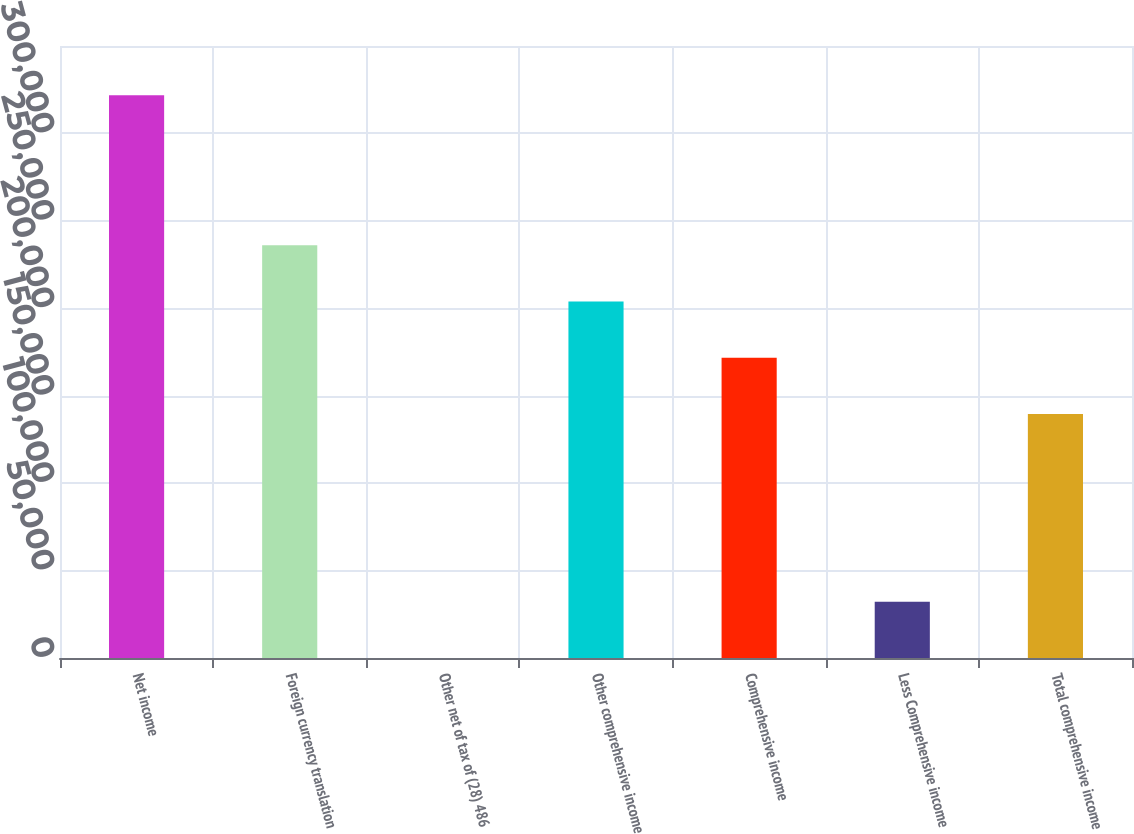<chart> <loc_0><loc_0><loc_500><loc_500><bar_chart><fcel>Net income<fcel>Foreign currency translation<fcel>Other net of tax of (28) 486<fcel>Other comprehensive income<fcel>Comprehensive income<fcel>Less Comprehensive income<fcel>Total comprehensive income<nl><fcel>321824<fcel>236038<fcel>59<fcel>203861<fcel>171684<fcel>32235.5<fcel>139508<nl></chart> 